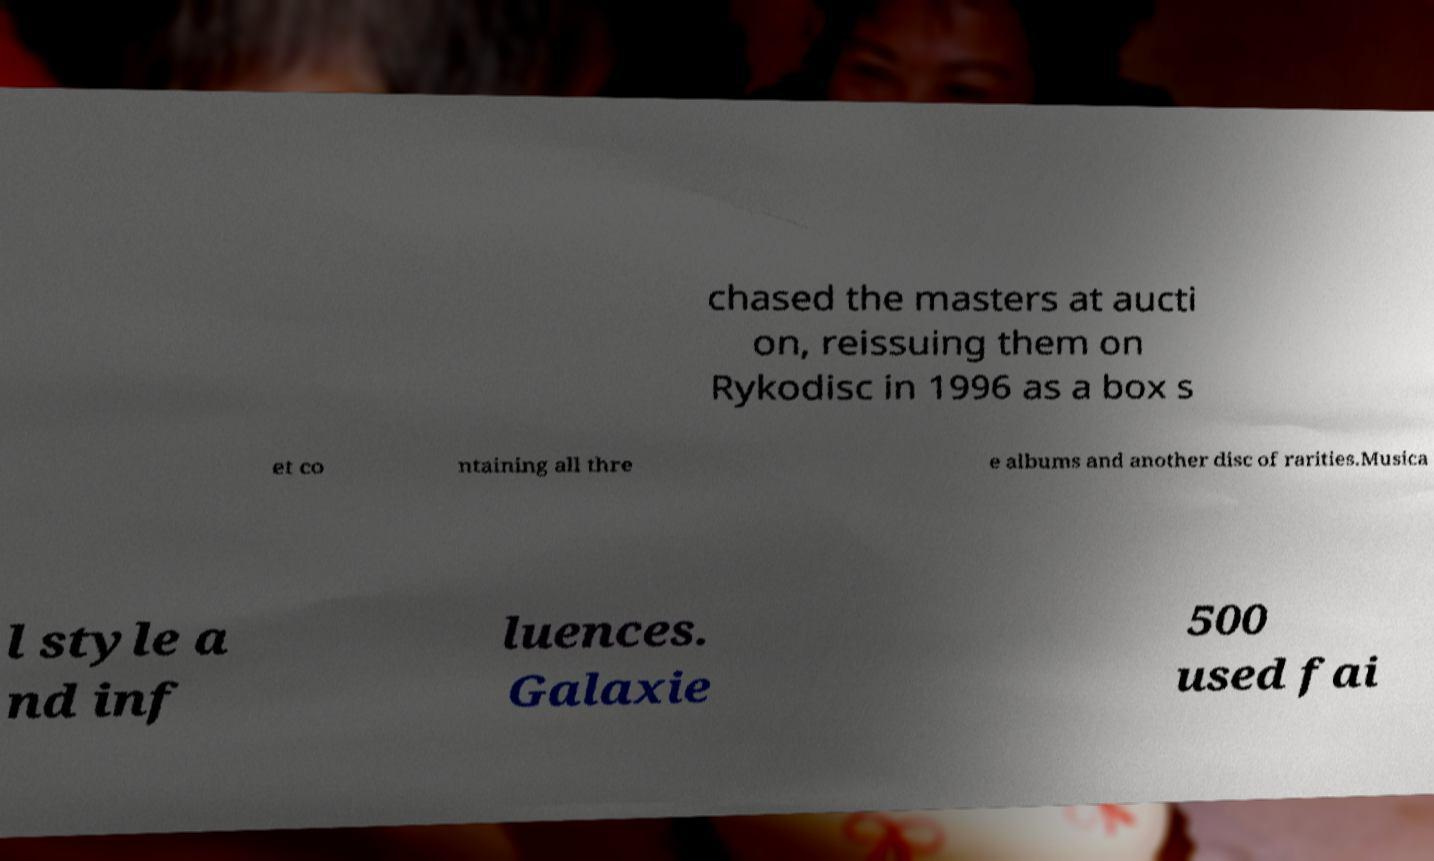What messages or text are displayed in this image? I need them in a readable, typed format. chased the masters at aucti on, reissuing them on Rykodisc in 1996 as a box s et co ntaining all thre e albums and another disc of rarities.Musica l style a nd inf luences. Galaxie 500 used fai 